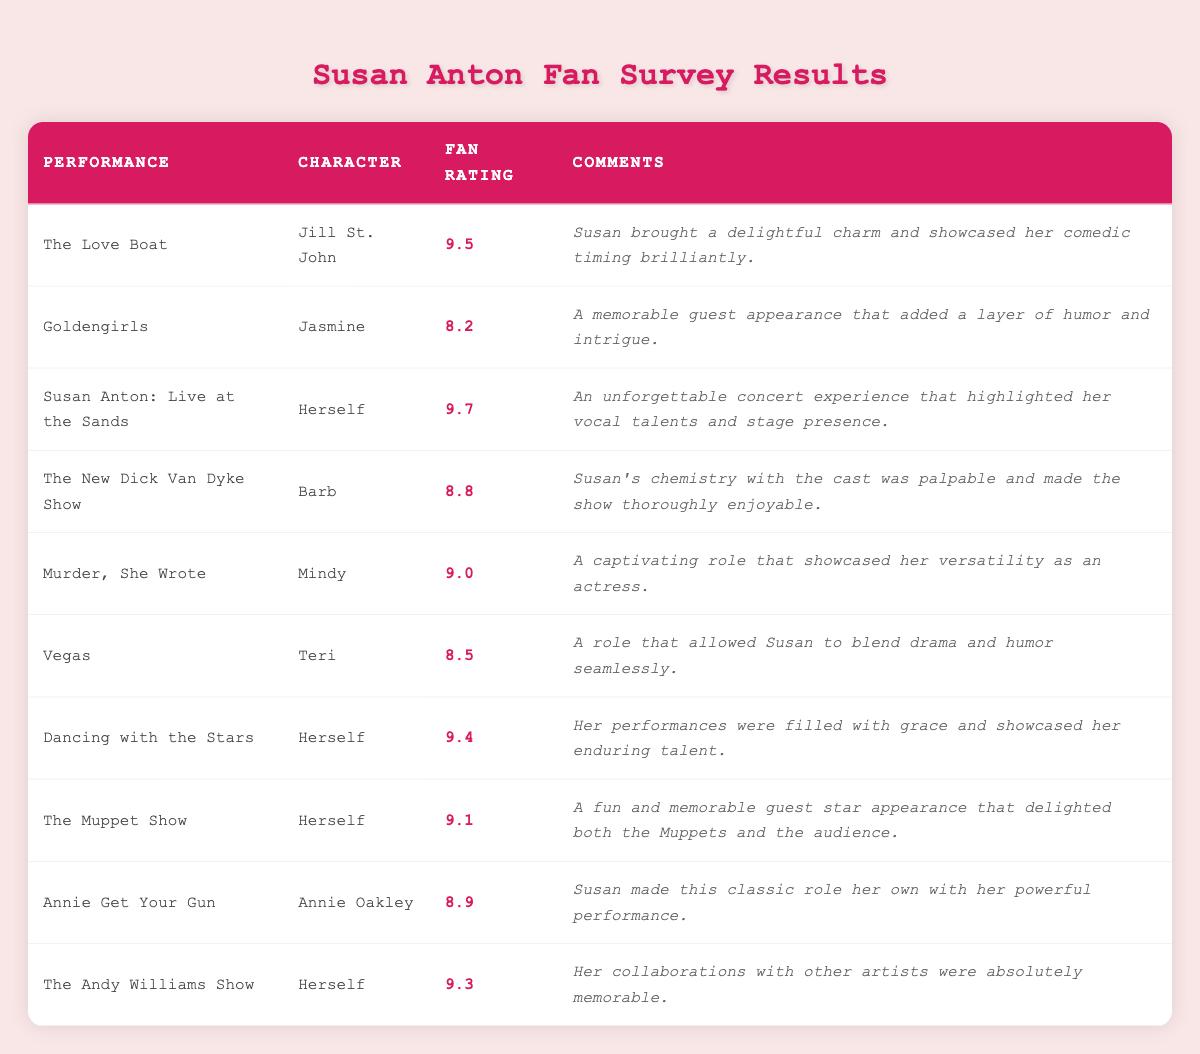What performance received the highest fan rating? The performance with the highest fan rating is "Susan Anton: Live at the Sands," which has a rating of 9.7.
Answer: 9.7 What character did Susan Anton portray in "Murder, She Wrote"? In "Murder, She Wrote," Susan Anton portrayed the character Mindy.
Answer: Mindy How many performances received a fan rating of 9.0 or higher? To find the number of performances with a rating of 9.0 or higher, we can count the instances: "The Love Boat" (9.5), "Susan Anton: Live at the Sands" (9.7), "Dancing with the Stars" (9.4), "The Muppet Show" (9.1), "Murder, She Wrote" (9.0), and "The Andy Williams Show" (9.3). That totals to 6 performances.
Answer: 6 What is the average fan rating of the performances listed? The total fan rating is 9.5 + 8.2 + 9.7 + 8.8 + 9.0 + 8.5 + 9.4 + 9.1 + 8.9 + 9.3 = 89.6. There are 10 performances, so the average is 89.6 / 10 = 8.96.
Answer: 8.96 Did Susan Anton showcase her comedic timing in any performances? Yes, she showcased her comedic timing brilliantly in "The Love Boat."
Answer: Yes Which performance allowed Susan to blend drama and humor seamlessly? In the performance "Vegas," Susan was able to blend drama and humor seamlessly.
Answer: Vegas Which character had the lowest fan rating and what was that rating? The character with the lowest fan rating was Jasmine from "Goldengirls," with a rating of 8.2.
Answer: Jasmine; 8.2 What was noted about Susan's performance in "Dancing with the Stars"? It was noted that her performances were filled with grace and showcased her enduring talent.
Answer: Grace and enduring talent How does the fan rating of "Annie Get Your Gun" compare to that of "The New Dick Van Dyke Show"? "Annie Get Your Gun" received a fan rating of 8.9, while "The New Dick Van Dyke Show" had a rating of 8.8. Thus, "Annie Get Your Gun" is slightly higher.
Answer: Annie Get Your Gun is higher Which performance featured collaborations with other artists? The performance "The Andy Williams Show" featured collaborations with other artists.
Answer: The Andy Williams Show 